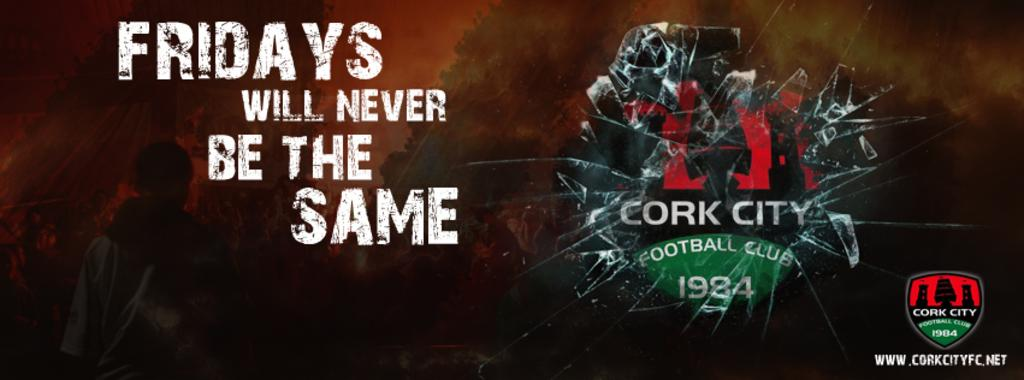<image>
Create a compact narrative representing the image presented. a FRIDAYS WILL NEVER BE THE SAME CORK CITY FOOTBALL CLUB 1984 ad. 